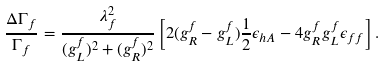<formula> <loc_0><loc_0><loc_500><loc_500>\frac { \Delta \Gamma _ { f } } { \Gamma _ { f } } = \frac { \lambda _ { f } ^ { 2 } } { ( g _ { L } ^ { f } ) ^ { 2 } + ( g _ { R } ^ { f } ) ^ { 2 } } \left [ 2 ( g _ { R } ^ { f } - g _ { L } ^ { f } ) \frac { 1 } { 2 } \epsilon _ { h A } - 4 g _ { R } ^ { f } g _ { L } ^ { f } \epsilon _ { f f } \right ] .</formula> 